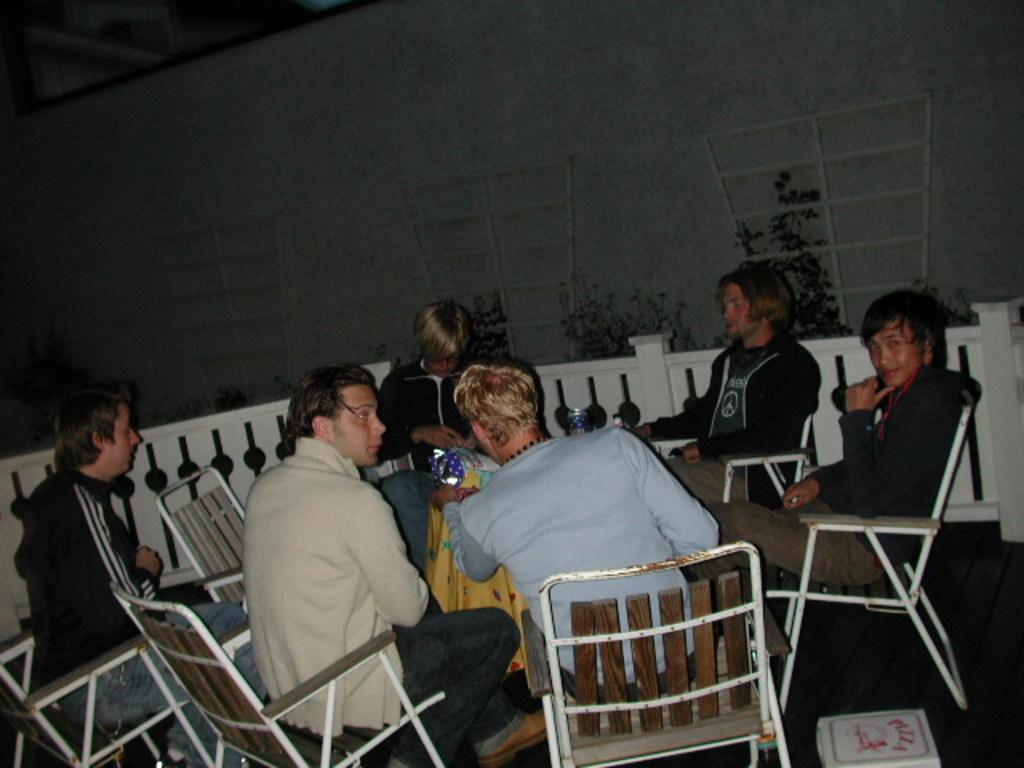What is the main subject of the image? The main subject of the image is the boys. What are the boys doing in the image? The boys are sitting around a table. What are the boys sitting on? The boys are on chairs. What can be seen on the table with the boys? There are bottles on the table. What can be seen in the background of the image? There are trees visible in the image. What type of writing can be seen on the string in the image? There is no string or writing present in the image. 